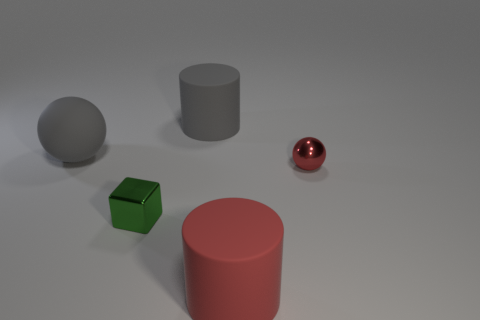What material is the tiny block in front of the large gray rubber ball?
Offer a terse response. Metal. The tiny sphere has what color?
Provide a succinct answer. Red. Does the cylinder that is in front of the red ball have the same size as the gray sphere?
Your response must be concise. Yes. What is the material of the big object in front of the small metal object behind the small object that is to the left of the large gray rubber cylinder?
Provide a succinct answer. Rubber. Is the color of the object that is behind the big gray ball the same as the thing on the left side of the green metallic object?
Make the answer very short. Yes. What is the material of the large cylinder behind the matte cylinder in front of the large sphere?
Your answer should be very brief. Rubber. There is a sphere that is the same size as the gray cylinder; what is its color?
Your answer should be very brief. Gray. Does the tiny red metallic object have the same shape as the big matte object that is on the left side of the gray cylinder?
Ensure brevity in your answer.  Yes. There is a large matte thing that is the same color as the small shiny ball; what shape is it?
Provide a succinct answer. Cylinder. There is a tiny metal object on the left side of the big gray thing that is to the right of the tiny green block; how many red metallic balls are to the left of it?
Provide a short and direct response. 0. 